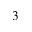<formula> <loc_0><loc_0><loc_500><loc_500>_ { 3 }</formula> 